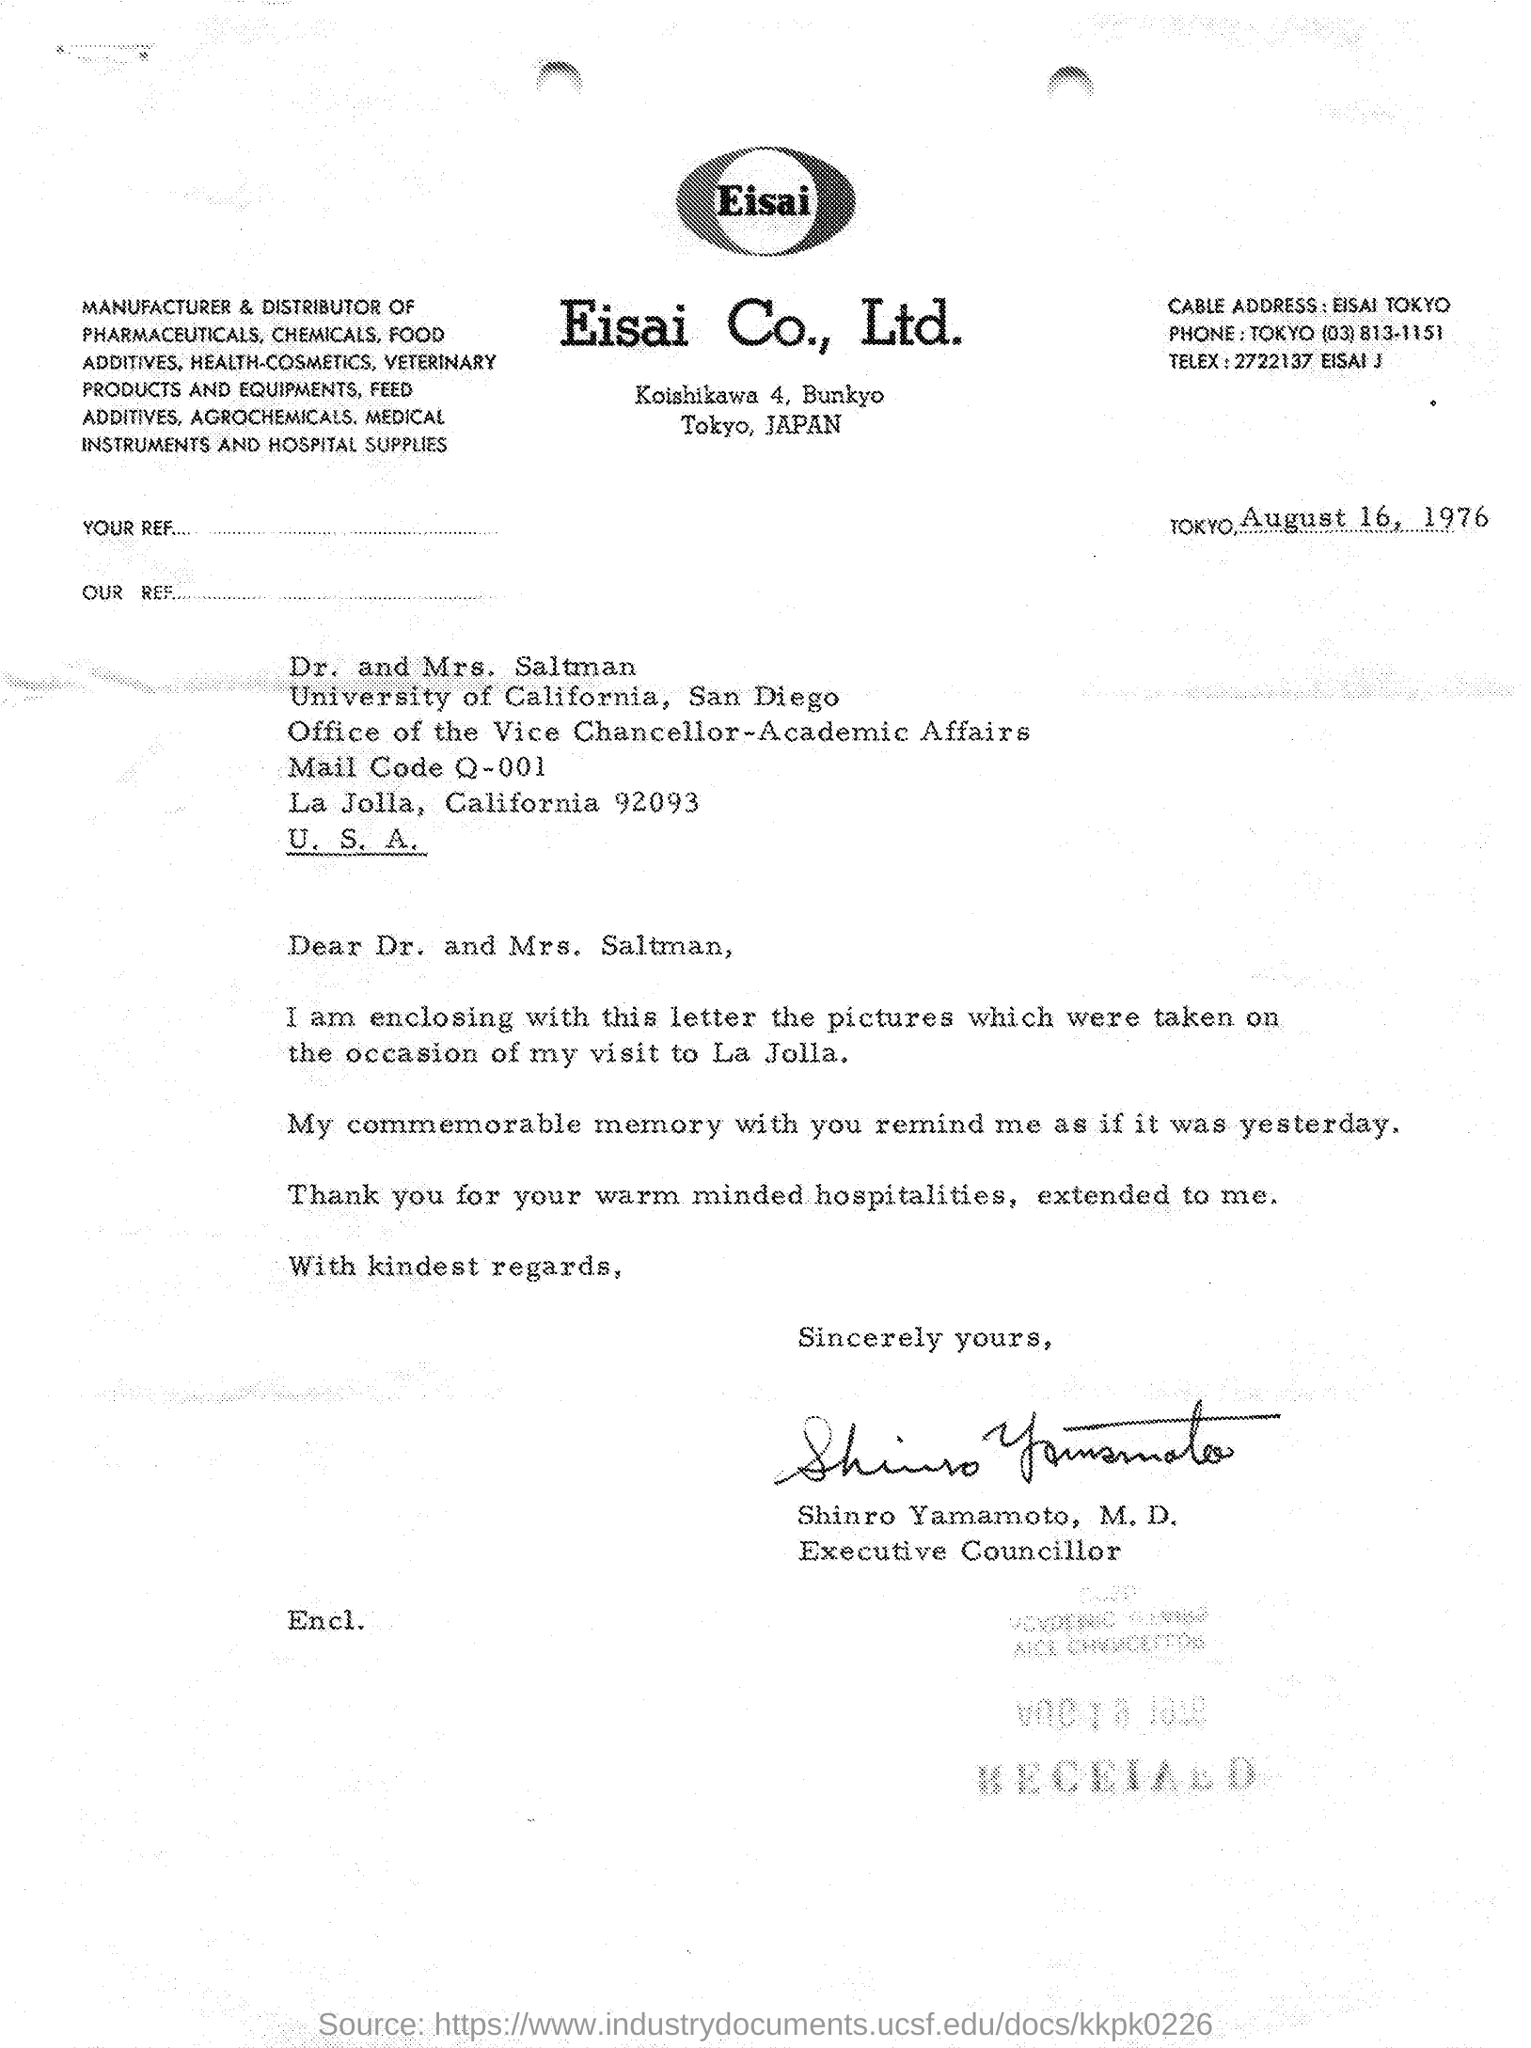What is the date mentioned in the given letter ?
Make the answer very short. August 16, 1976. What is the cable address mentioned in the given letter ?
Your answer should be very brief. Eisai tokyo. What is the phone number(tokyo) mentioned in the given letter ?
Offer a terse response. (03) 813-1151. Who's sign was there at the end of the letter ?
Keep it short and to the point. Shinro yamamoto. What is the designation of shinro yamamoto ?
Offer a terse response. Executive councillor. To which university mr. and mrs. saltman belongs to ?
Offer a very short reply. University of california. What is the name of the company ltd. mentioned in the given letter ?
Your response must be concise. Eisai Co., Ltd. What is the telex mentioned in the given letter ?
Your response must be concise. 2722137. 